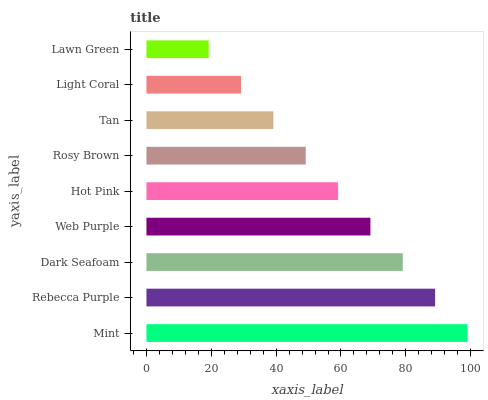Is Lawn Green the minimum?
Answer yes or no. Yes. Is Mint the maximum?
Answer yes or no. Yes. Is Rebecca Purple the minimum?
Answer yes or no. No. Is Rebecca Purple the maximum?
Answer yes or no. No. Is Mint greater than Rebecca Purple?
Answer yes or no. Yes. Is Rebecca Purple less than Mint?
Answer yes or no. Yes. Is Rebecca Purple greater than Mint?
Answer yes or no. No. Is Mint less than Rebecca Purple?
Answer yes or no. No. Is Hot Pink the high median?
Answer yes or no. Yes. Is Hot Pink the low median?
Answer yes or no. Yes. Is Rebecca Purple the high median?
Answer yes or no. No. Is Dark Seafoam the low median?
Answer yes or no. No. 